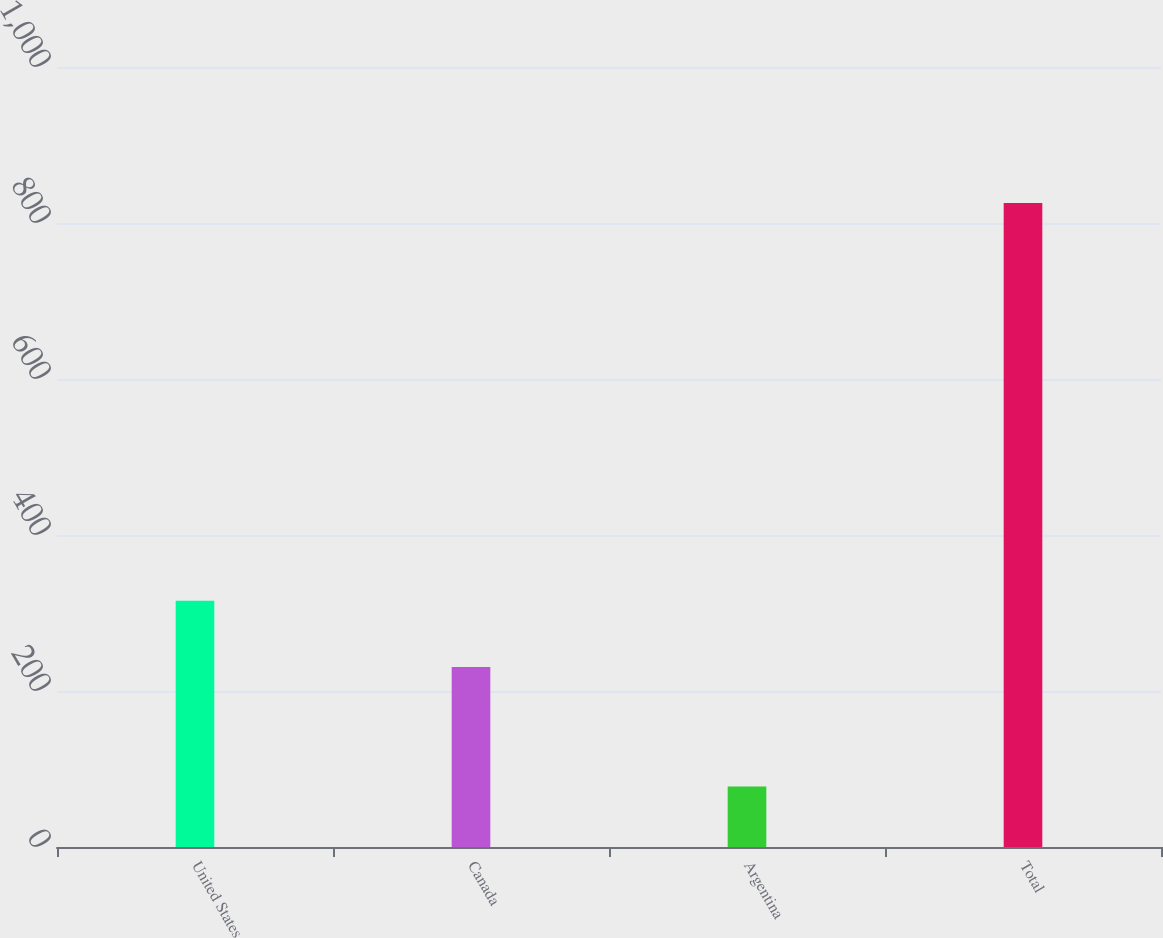<chart> <loc_0><loc_0><loc_500><loc_500><bar_chart><fcel>United States<fcel>Canada<fcel>Argentina<fcel>Total<nl><fcel>315.6<fcel>230.9<fcel>77.5<fcel>825.8<nl></chart> 